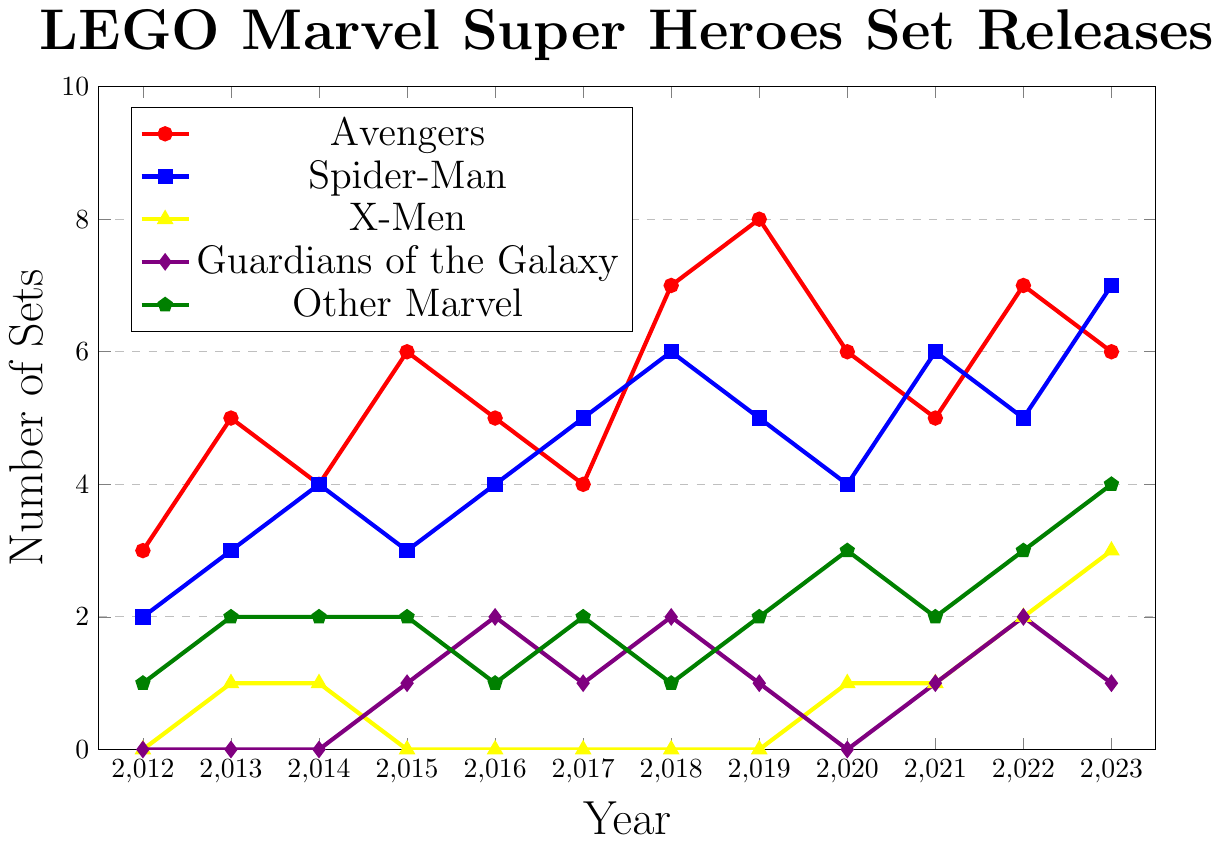What year had the highest number of LEGO sets released for the Avengers? The plot shows the Avengers series in red. By visually inspecting the red line, we can see the peak is at 2019.
Answer: 2019 Which franchise saw an increase in set releases each year from 2020 to 2023? Checking each franchise's line (color-coded), only the X-Men (yellow) shows a consistent upward trend from 2020 (1) to 2023 (3).
Answer: X-Men In what year did Spider-Man release the same number of sets as the Avengers? The Spider-Man series (blue) and Avengers series (red) intersect at 2016, where both have 5 sets.
Answer: 2016 How many total sets were released across all franchises in 2022? Sum up the sets for each franchise in 2022: Avengers (7) + Spider-Man (5) + X-Men (2) + Guardians of the Galaxy (2) + Other Marvel (3). The total is 7 + 5 + 2 + 2 + 3 = 19.
Answer: 19 Compare the number of LEGO sets released for Guardians of the Galaxy and Other Marvel in 2018. Which had more sets? Guardians of the Galaxy (purple) released 2 sets, while Other Marvel (green) released 1 set in 2018.
Answer: Guardians of the Galaxy What is the average number of sets released for Spider-Man between 2012 and 2015? Sum the sets released for Spider-Man (blue) from 2012 to 2015: 2 (2012) + 3 (2013) + 4 (2014) + 3 (2015) = 12. Divide by 4 years: 12/4 = 3.
Answer: 3 Did any franchise release zero sets in more than one year? If so, which one? Inspecting the plot, the X-Men (yellow) had zero releases from 2012 to 2013, 2015 to 2018, and the Guardians of the Galaxy (purple) had zero releases in 2012, 2013, and 2020.
Answer: X-Men, Guardians of the Galaxy Which year showed the largest increase in set releases for any single franchise? Comparing the yearly differences for each line, the largest increase is for Avengers (red) from 2014 (4) to 2015 (6) with a difference of 2; Spider-Man (blue) from 2017 (5) to 2018 (6) is 1; X-Men (yellow) from 2022 (2) to 2023 (3) is 1; Guardians (purple) from 2020 (0) to 2021 (1) is 1; Other Marvel (green) from 2022 (3) to 2023 (4) is 1. So, for Avengers, the largest increase is from 2014 to 2015.
Answer: 2014 to 2015 How many more sets did the Avengers release than the X-Men in 2023? In 2023, the Avengers (red) released 6 sets, and the X-Men (yellow) released 3 sets. The difference is 6 - 3 = 3.
Answer: 3 